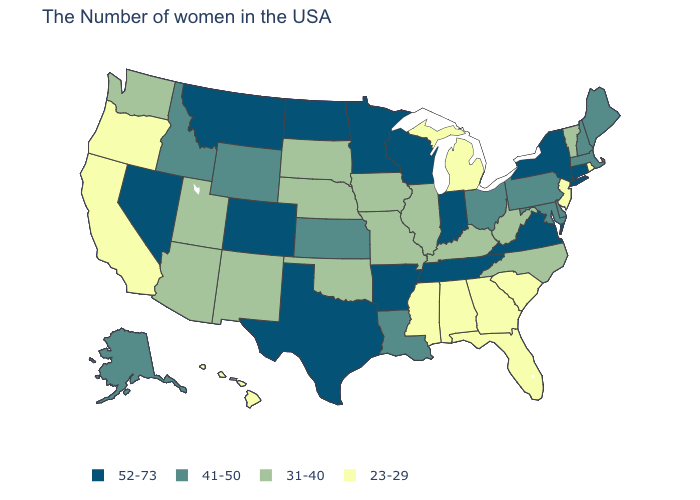What is the value of Maine?
Answer briefly. 41-50. Which states have the highest value in the USA?
Quick response, please. Connecticut, New York, Virginia, Indiana, Tennessee, Wisconsin, Arkansas, Minnesota, Texas, North Dakota, Colorado, Montana, Nevada. Does the first symbol in the legend represent the smallest category?
Short answer required. No. Among the states that border Wyoming , does Colorado have the highest value?
Be succinct. Yes. What is the highest value in states that border Massachusetts?
Quick response, please. 52-73. Which states have the lowest value in the South?
Write a very short answer. South Carolina, Florida, Georgia, Alabama, Mississippi. What is the value of California?
Keep it brief. 23-29. What is the lowest value in states that border Nevada?
Concise answer only. 23-29. Which states have the lowest value in the USA?
Keep it brief. Rhode Island, New Jersey, South Carolina, Florida, Georgia, Michigan, Alabama, Mississippi, California, Oregon, Hawaii. Which states have the lowest value in the USA?
Answer briefly. Rhode Island, New Jersey, South Carolina, Florida, Georgia, Michigan, Alabama, Mississippi, California, Oregon, Hawaii. Does Washington have the highest value in the USA?
Quick response, please. No. Name the states that have a value in the range 52-73?
Quick response, please. Connecticut, New York, Virginia, Indiana, Tennessee, Wisconsin, Arkansas, Minnesota, Texas, North Dakota, Colorado, Montana, Nevada. Name the states that have a value in the range 31-40?
Short answer required. Vermont, North Carolina, West Virginia, Kentucky, Illinois, Missouri, Iowa, Nebraska, Oklahoma, South Dakota, New Mexico, Utah, Arizona, Washington. What is the highest value in the USA?
Be succinct. 52-73. 